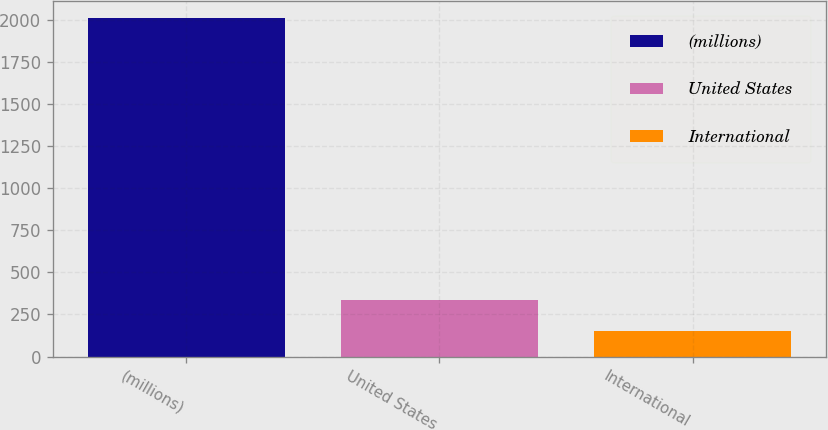<chart> <loc_0><loc_0><loc_500><loc_500><bar_chart><fcel>(millions)<fcel>United States<fcel>International<nl><fcel>2011<fcel>338.7<fcel>152.7<nl></chart> 